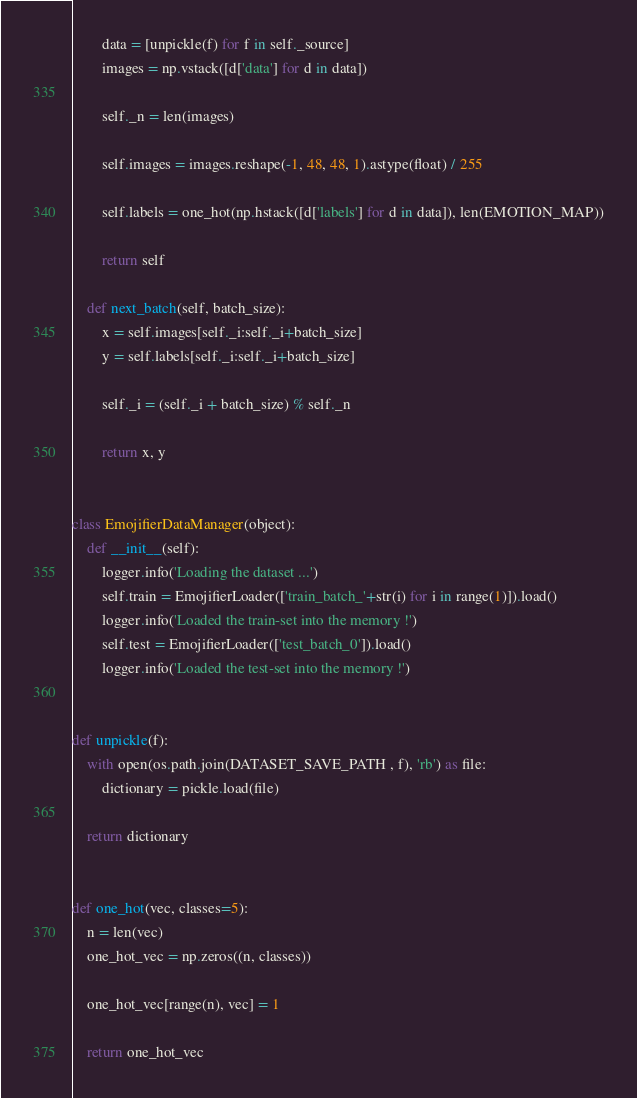Convert code to text. <code><loc_0><loc_0><loc_500><loc_500><_Python_>        data = [unpickle(f) for f in self._source]
        images = np.vstack([d['data'] for d in data])

        self._n = len(images)

        self.images = images.reshape(-1, 48, 48, 1).astype(float) / 255

        self.labels = one_hot(np.hstack([d['labels'] for d in data]), len(EMOTION_MAP))

        return self

    def next_batch(self, batch_size):
        x = self.images[self._i:self._i+batch_size]
        y = self.labels[self._i:self._i+batch_size]

        self._i = (self._i + batch_size) % self._n

        return x, y


class EmojifierDataManager(object):
    def __init__(self):
        logger.info('Loading the dataset ...')
        self.train = EmojifierLoader(['train_batch_'+str(i) for i in range(1)]).load()
        logger.info('Loaded the train-set into the memory !')
        self.test = EmojifierLoader(['test_batch_0']).load()
        logger.info('Loaded the test-set into the memory !')


def unpickle(f):
    with open(os.path.join(DATASET_SAVE_PATH , f), 'rb') as file:
        dictionary = pickle.load(file)

    return dictionary


def one_hot(vec, classes=5):
    n = len(vec)
    one_hot_vec = np.zeros((n, classes))

    one_hot_vec[range(n), vec] = 1

    return one_hot_vec
</code> 